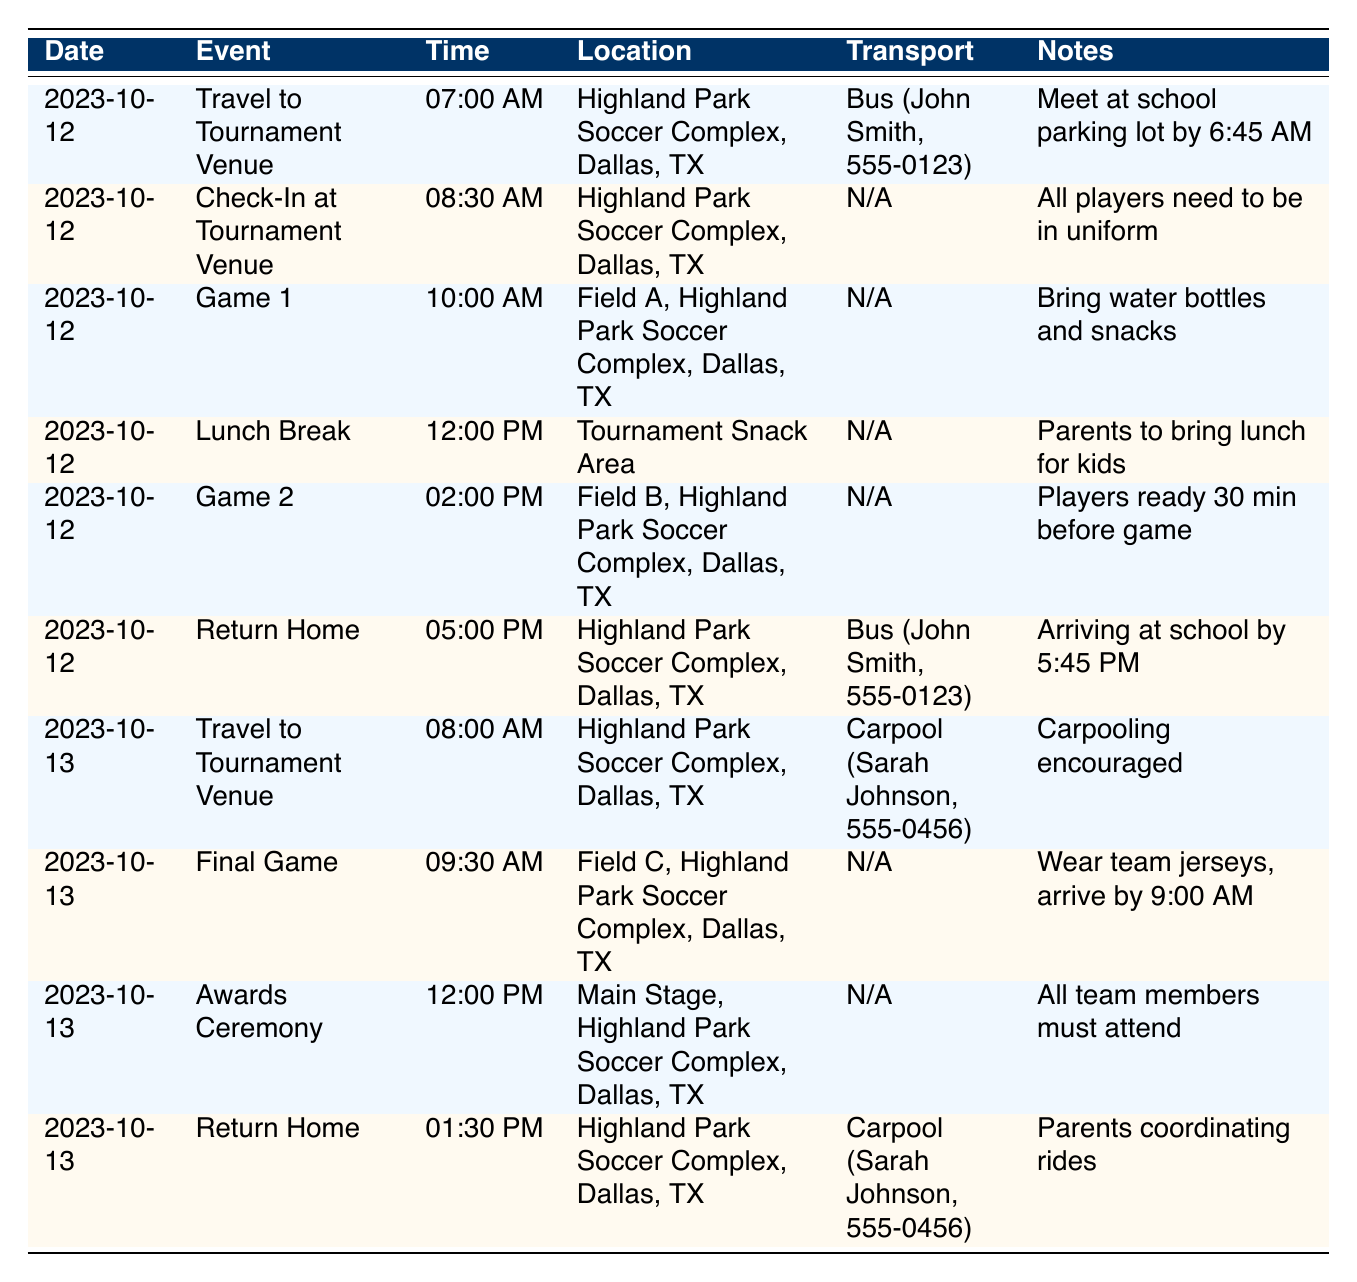What time do we need to meet for the bus to the tournament on October 12? The entry for "Travel to Tournament Venue" on October 12 shows the departure time is set for 7:00 AM. The additional note states that everyone should meet at the school parking lot by 6:45 AM.
Answer: 6:45 AM Who is driving the bus on October 12? Under the "Transport" column for the "Travel to Tournament Venue" event on October 12, the driver is indicated as John Smith.
Answer: John Smith Is there a lunch break on October 12? The table lists a "Lunch Break" on October 12 at 12:00 PM, confirming that there is a dedicated time for lunch.
Answer: Yes How many games are scheduled for October 12? Reviewing the entries for October 12, there are two listed games: "Game 1" at 10:00 AM and "Game 2" at 2:00 PM, totaling two games.
Answer: 2 On which day do parents need to coordinate rides home for players? The table indicates that on October 13, for the "Return Home" activity, the transport mode is listed as "Carpool" with a note stating that parents are coordinating rides for players.
Answer: October 13 What is the difference in departure times for the travel to the tournament on October 12 and October 13? The travel time on October 12 is 7:00 AM and on October 13 is 8:00 AM. To find the difference, 8:00 AM - 7:00 AM results in a 1-hour difference.
Answer: 1 hour Do all players need to bring their uniforms on October 12? The "Check-In at Tournament Venue" entry for October 12 notes that "All players need to be in uniform," confirming they must wear their uniforms.
Answer: Yes What time should players arrive for the final game on October 13? For the "Final Game" on October 13, the table states that players should arrive by 9:00 AM, detailed in the additional notes.
Answer: 9:00 AM How many events are scheduled for October 13? Looking at the entries for October 13, there are three listed events: "Travel to Tournament Venue," "Final Game," and "Awards Ceremony," giving a total of three events.
Answer: 3 